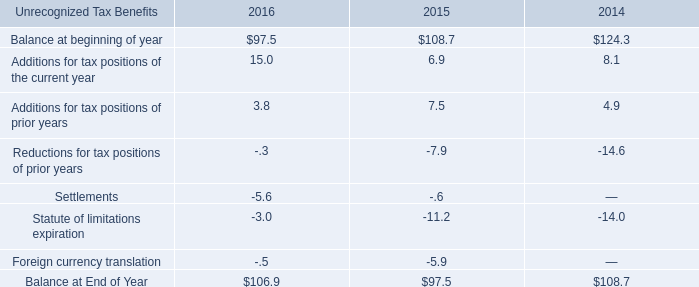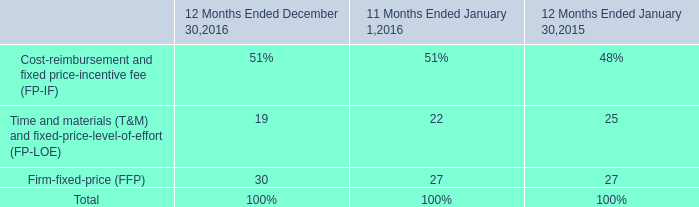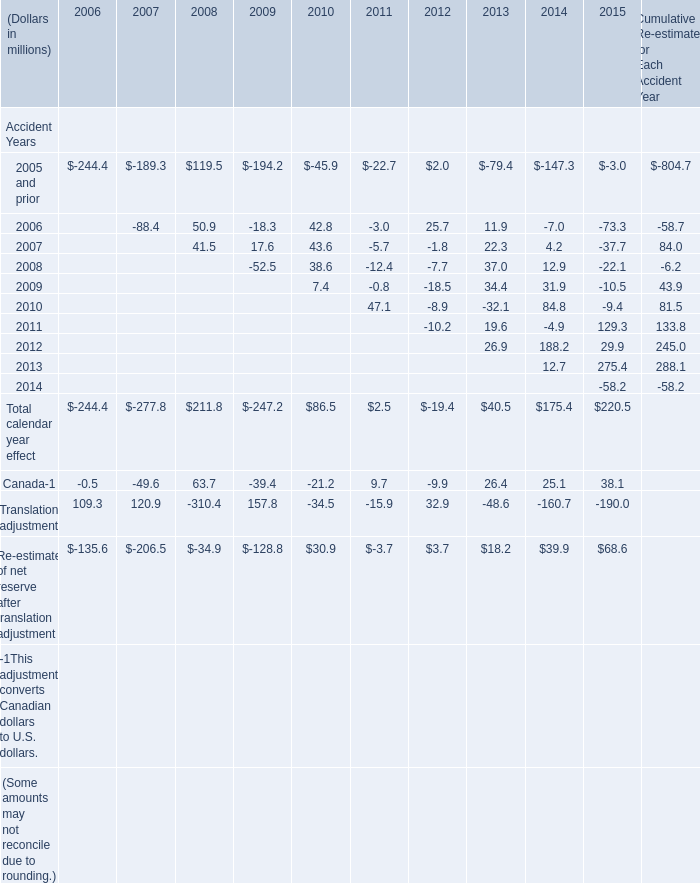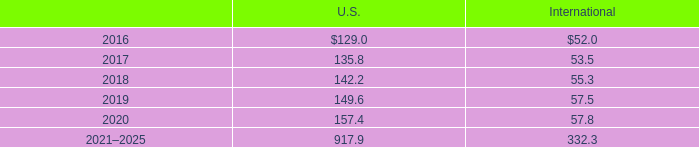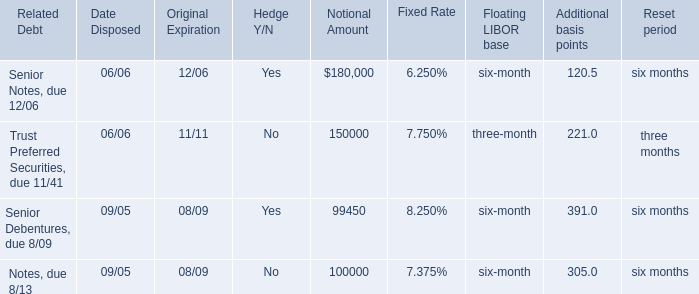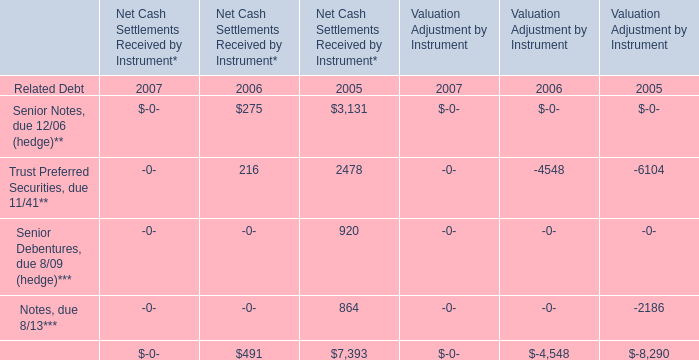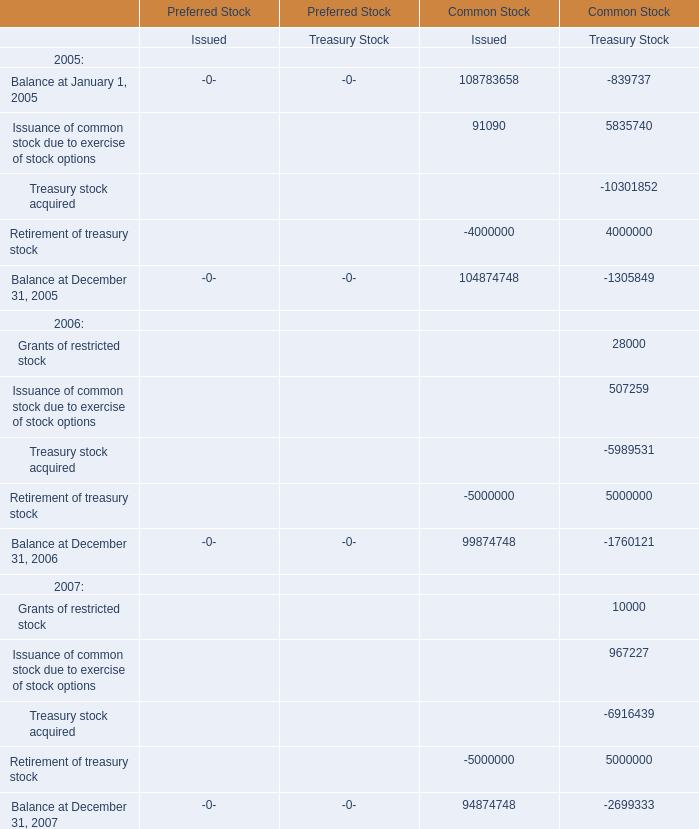What is the sum of Balance at January 1, 2005, Issuance of common stock due to exercise of stock options and Treasury stock acquired in 2005? 
Computations: ((((108783658 - 839737) + 91090) + 5835740) - 10301852)
Answer: 103568899.0. 